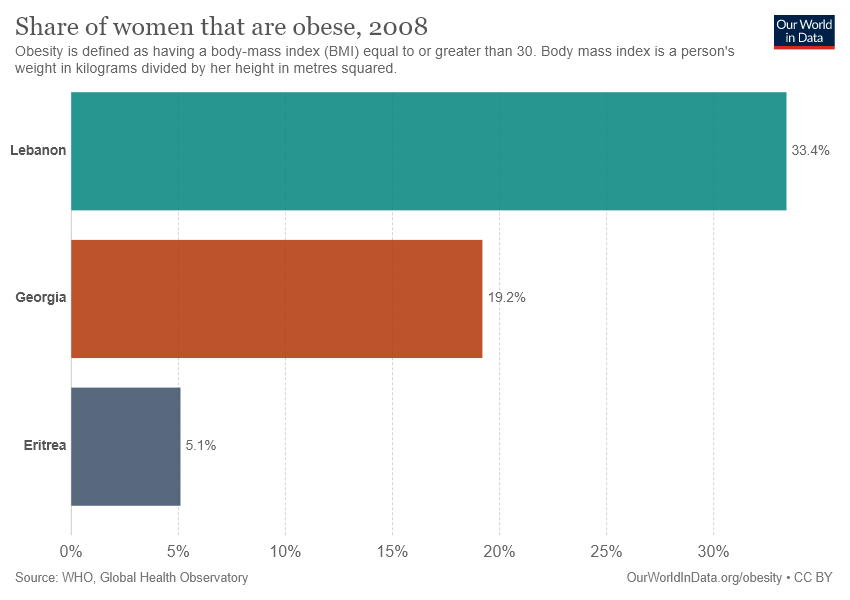Point out several critical features in this image. The highest value on the bar graph is 0.334. The ratio is the highest value compared to the lowest value, which is approximately 6.549019607843137... 